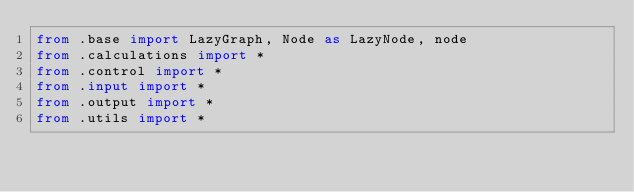Convert code to text. <code><loc_0><loc_0><loc_500><loc_500><_Python_>from .base import LazyGraph, Node as LazyNode, node
from .calculations import *
from .control import *
from .input import *
from .output import *
from .utils import *
</code> 